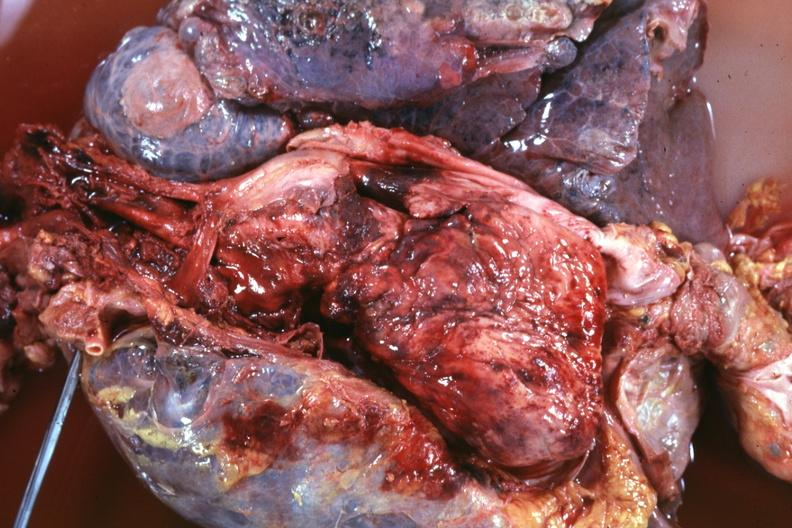what is present?
Answer the question using a single word or phrase. Hematologic 